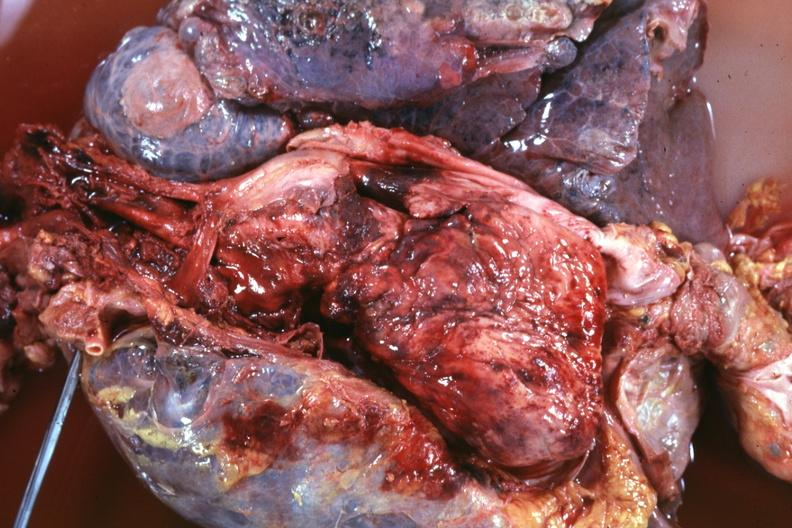what is present?
Answer the question using a single word or phrase. Hematologic 